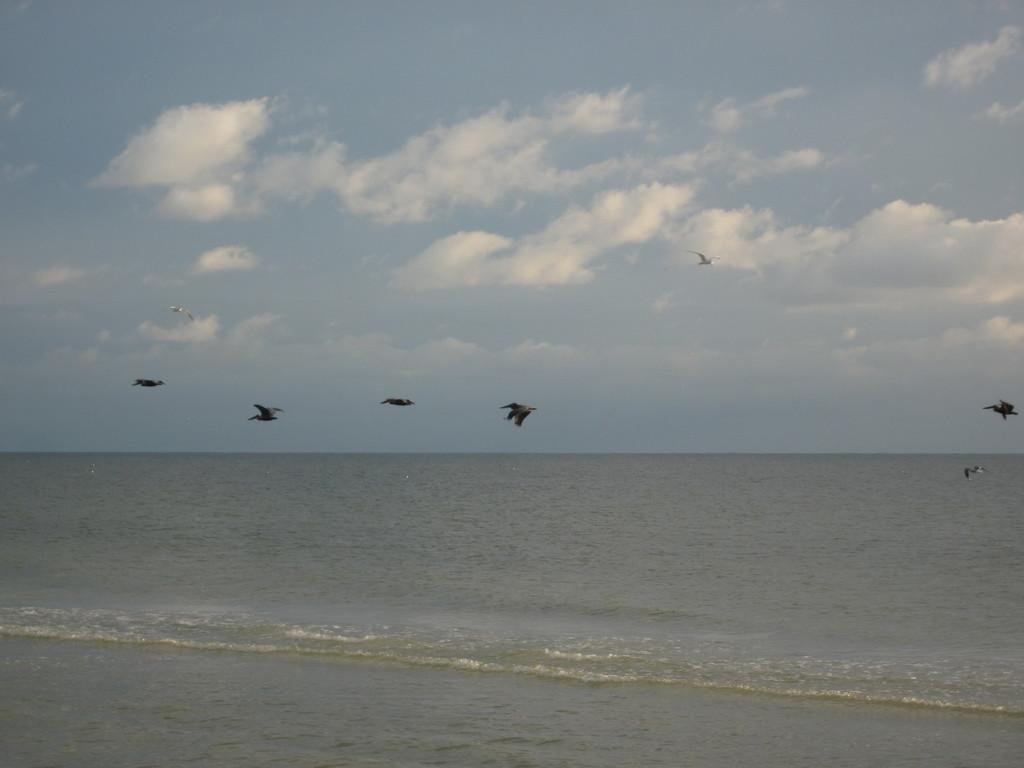Could you give a brief overview of what you see in this image? In this picture we can see there are some birds flying in the air and under the birds there is water and behind the birds there is a sky. 